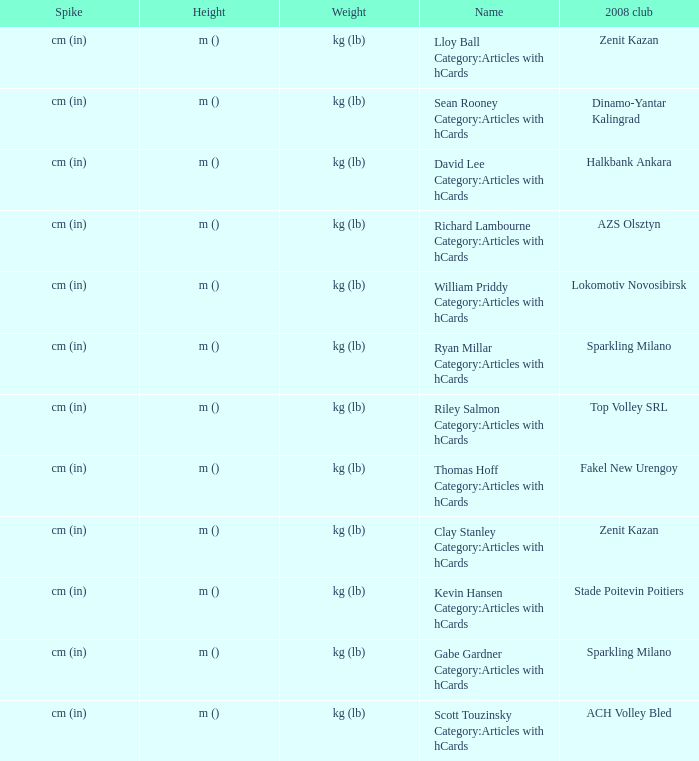What is the spike for the 2008 club of Lokomotiv Novosibirsk? Cm (in). 